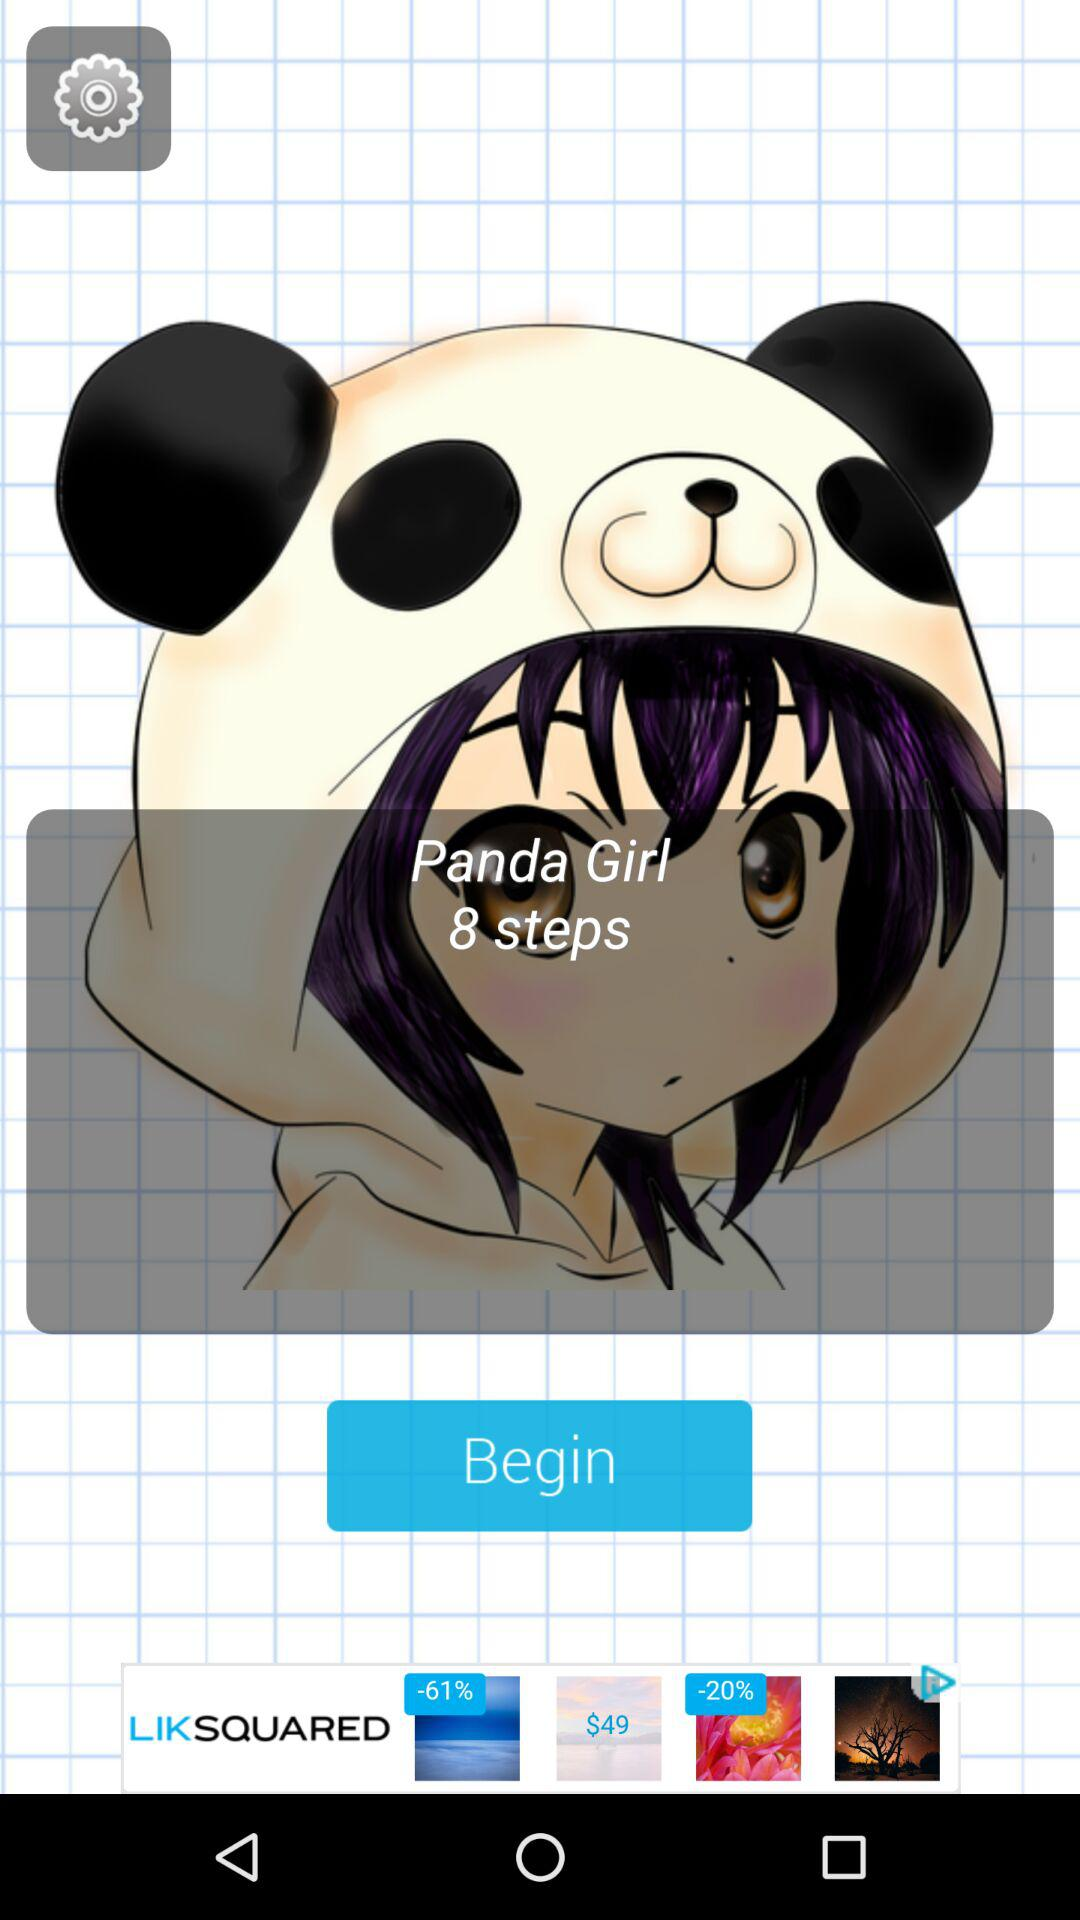How many steps are there? There are 8 steps. 